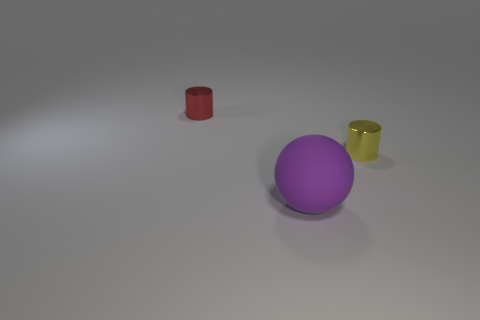What objects can you identify in the image, and how would you describe their arrangement? The image contains three distinct objects: a purple sphere in the center, a red cylinder to the left, and a yellow cylinder to the right. The objects are placed on a flat surface, arranged in a roughly triangular formation with ample space between them. The lighting suggests an indoor setting with a soft, diffuse light source. 